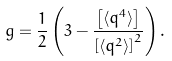<formula> <loc_0><loc_0><loc_500><loc_500>g = \frac { 1 } { 2 } \left ( 3 - \frac { \left [ \langle q ^ { 4 } \rangle \right ] } { \left [ \langle q ^ { 2 } \rangle \right ] ^ { 2 } } \right ) .</formula> 